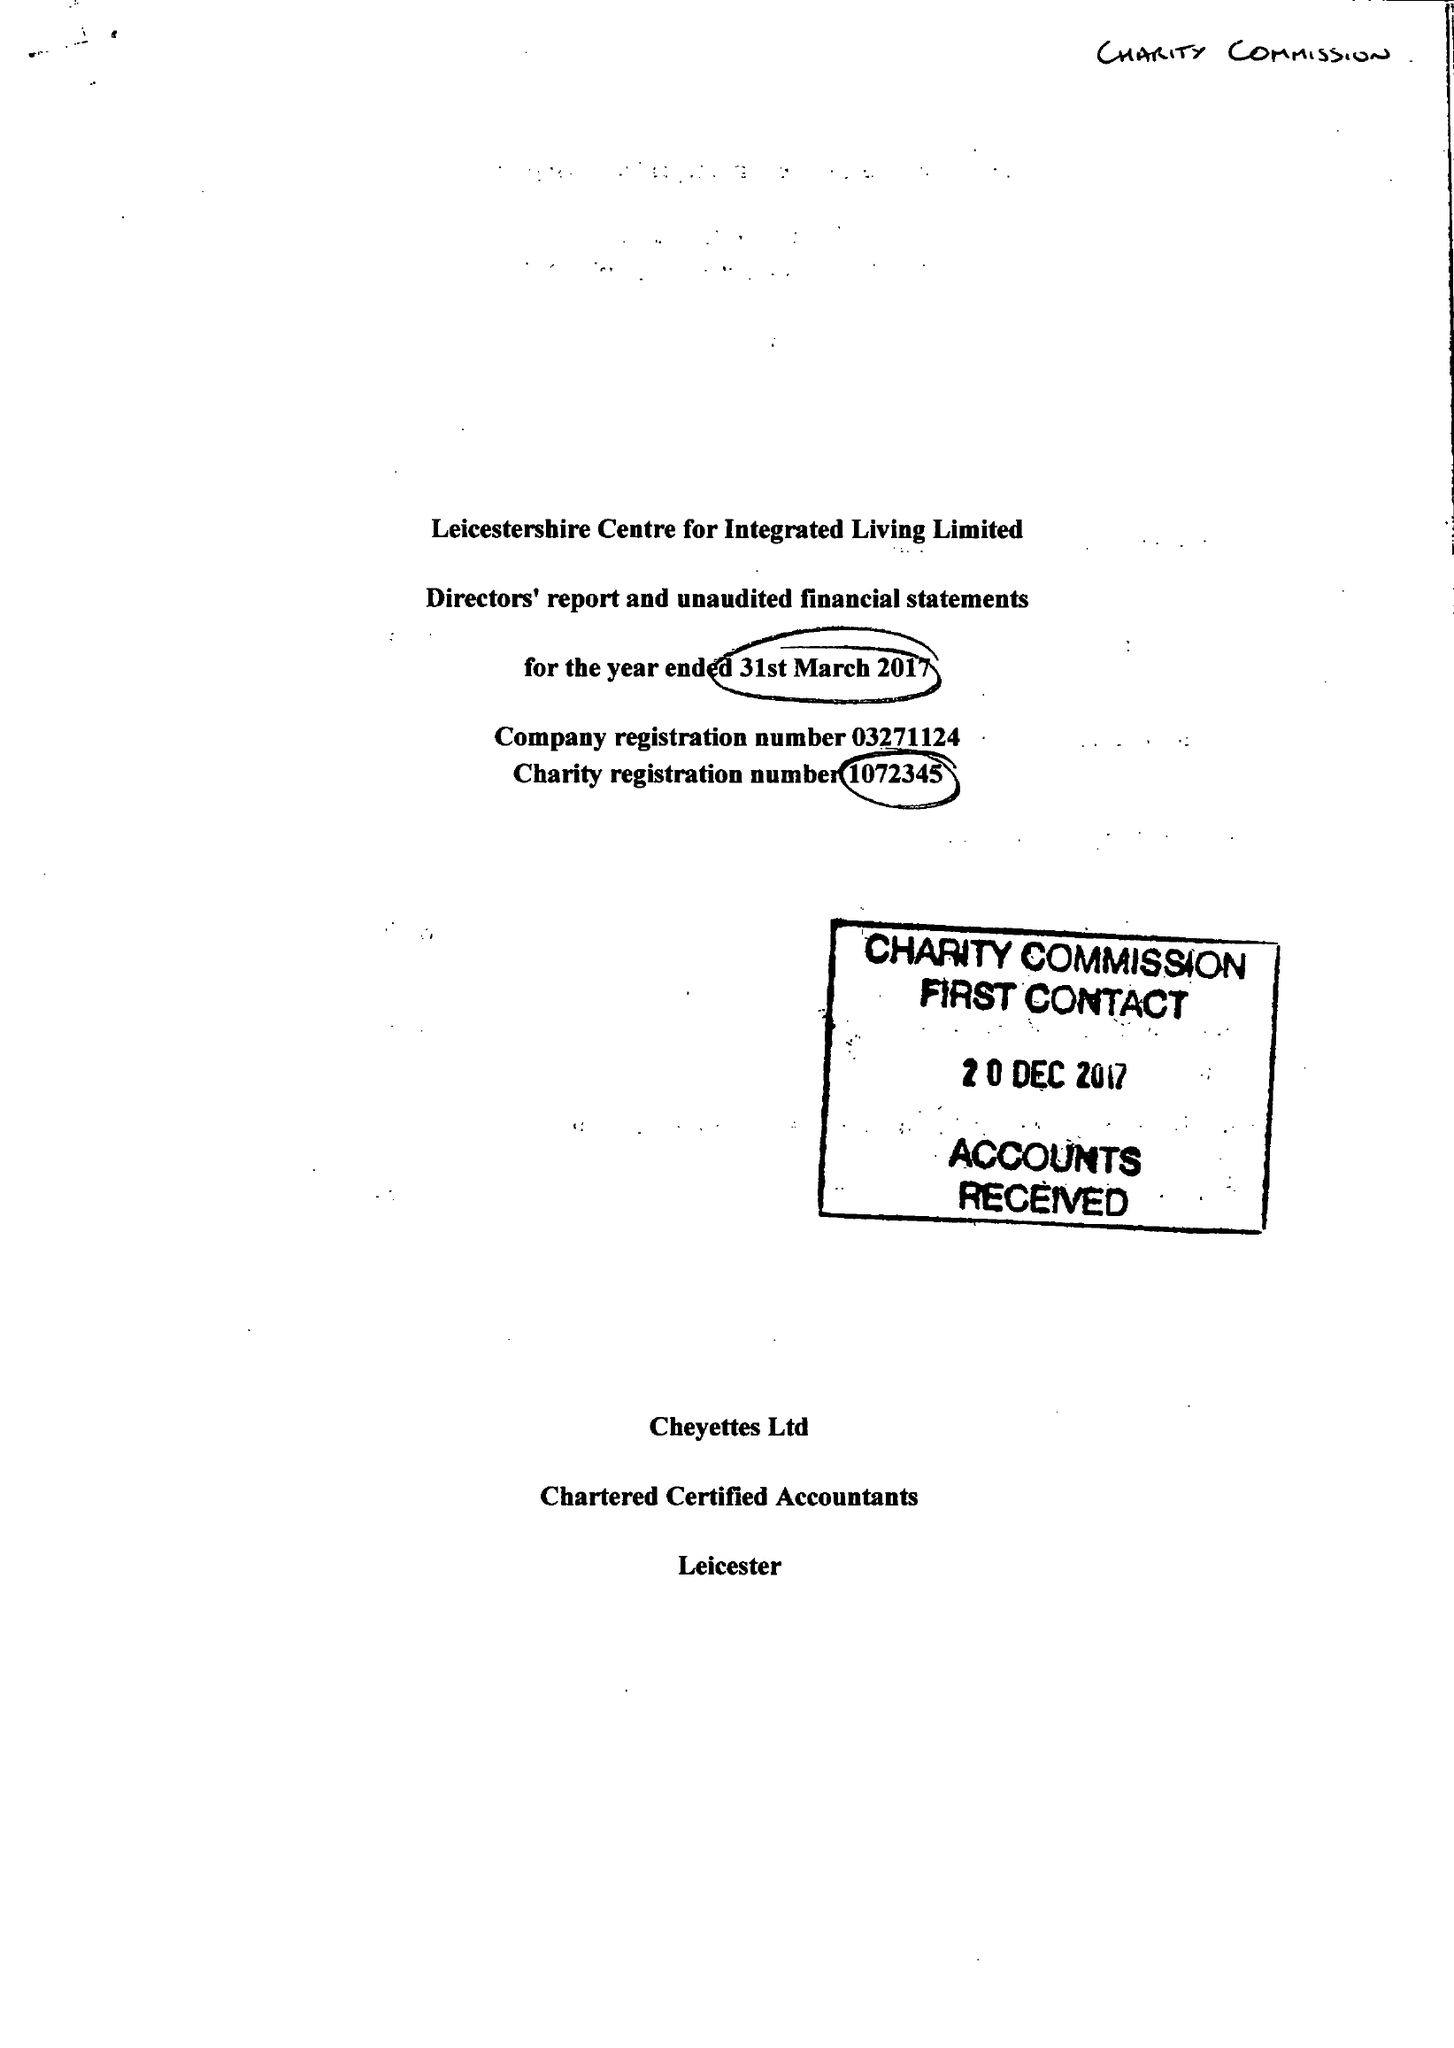What is the value for the address__post_town?
Answer the question using a single word or phrase. LEICESTER 